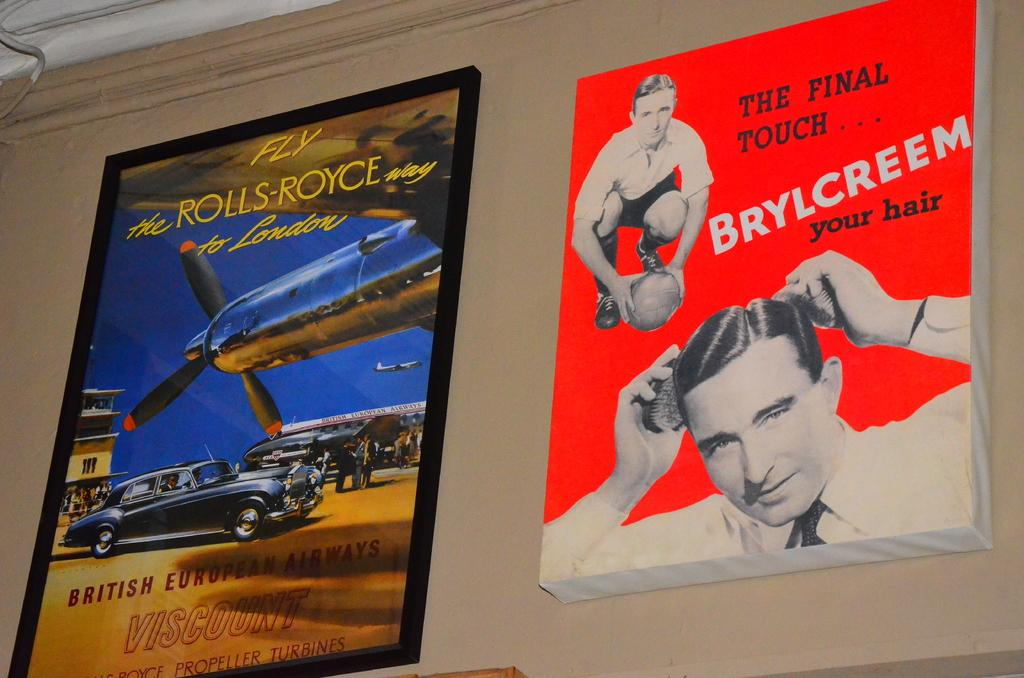<image>
Create a compact narrative representing the image presented. An advertisment for Brylcreem hair tonic next to an ad for a Rolls Royce. 